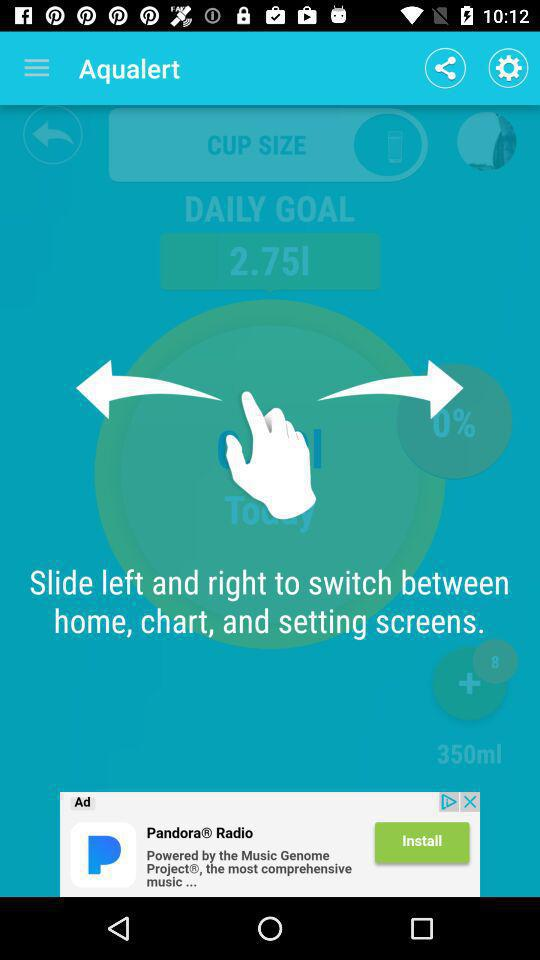How many ml is the cup size?
Answer the question using a single word or phrase. 350 